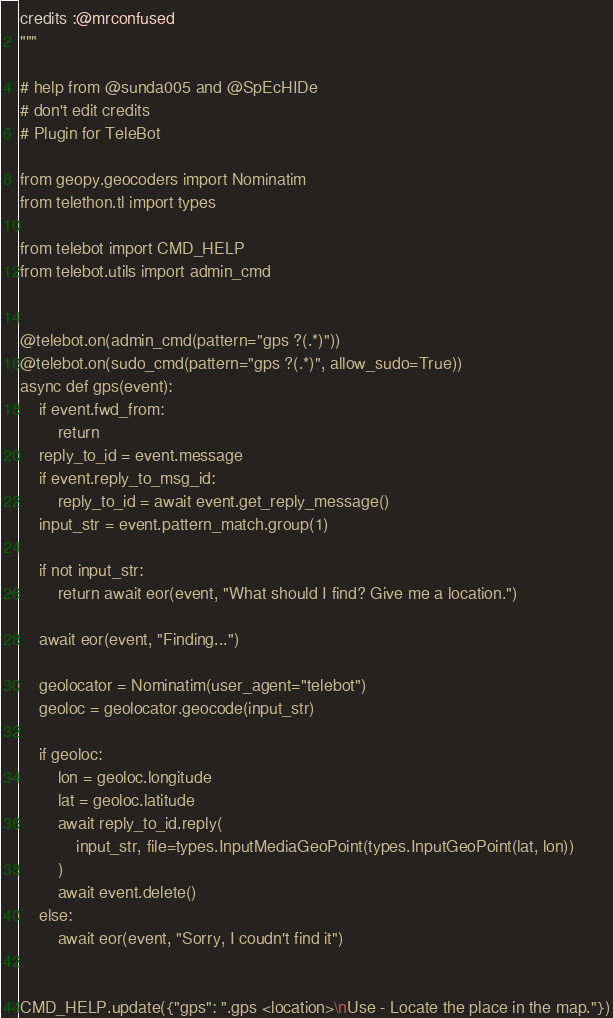<code> <loc_0><loc_0><loc_500><loc_500><_Python_>credits :@mrconfused
"""

# help from @sunda005 and @SpEcHIDe
# don't edit credits
# Plugin for TeleBot

from geopy.geocoders import Nominatim
from telethon.tl import types

from telebot import CMD_HELP
from telebot.utils import admin_cmd


@telebot.on(admin_cmd(pattern="gps ?(.*)"))
@telebot.on(sudo_cmd(pattern="gps ?(.*)", allow_sudo=True))
async def gps(event):
    if event.fwd_from:
        return
    reply_to_id = event.message
    if event.reply_to_msg_id:
        reply_to_id = await event.get_reply_message()
    input_str = event.pattern_match.group(1)

    if not input_str:
        return await eor(event, "What should I find? Give me a location.")

    await eor(event, "Finding...")

    geolocator = Nominatim(user_agent="telebot")
    geoloc = geolocator.geocode(input_str)

    if geoloc:
        lon = geoloc.longitude
        lat = geoloc.latitude
        await reply_to_id.reply(
            input_str, file=types.InputMediaGeoPoint(types.InputGeoPoint(lat, lon))
        )
        await event.delete()
    else:
        await eor(event, "Sorry, I coudn't find it")


CMD_HELP.update({"gps": ".gps <location>\nUse - Locate the place in the map."})
</code> 